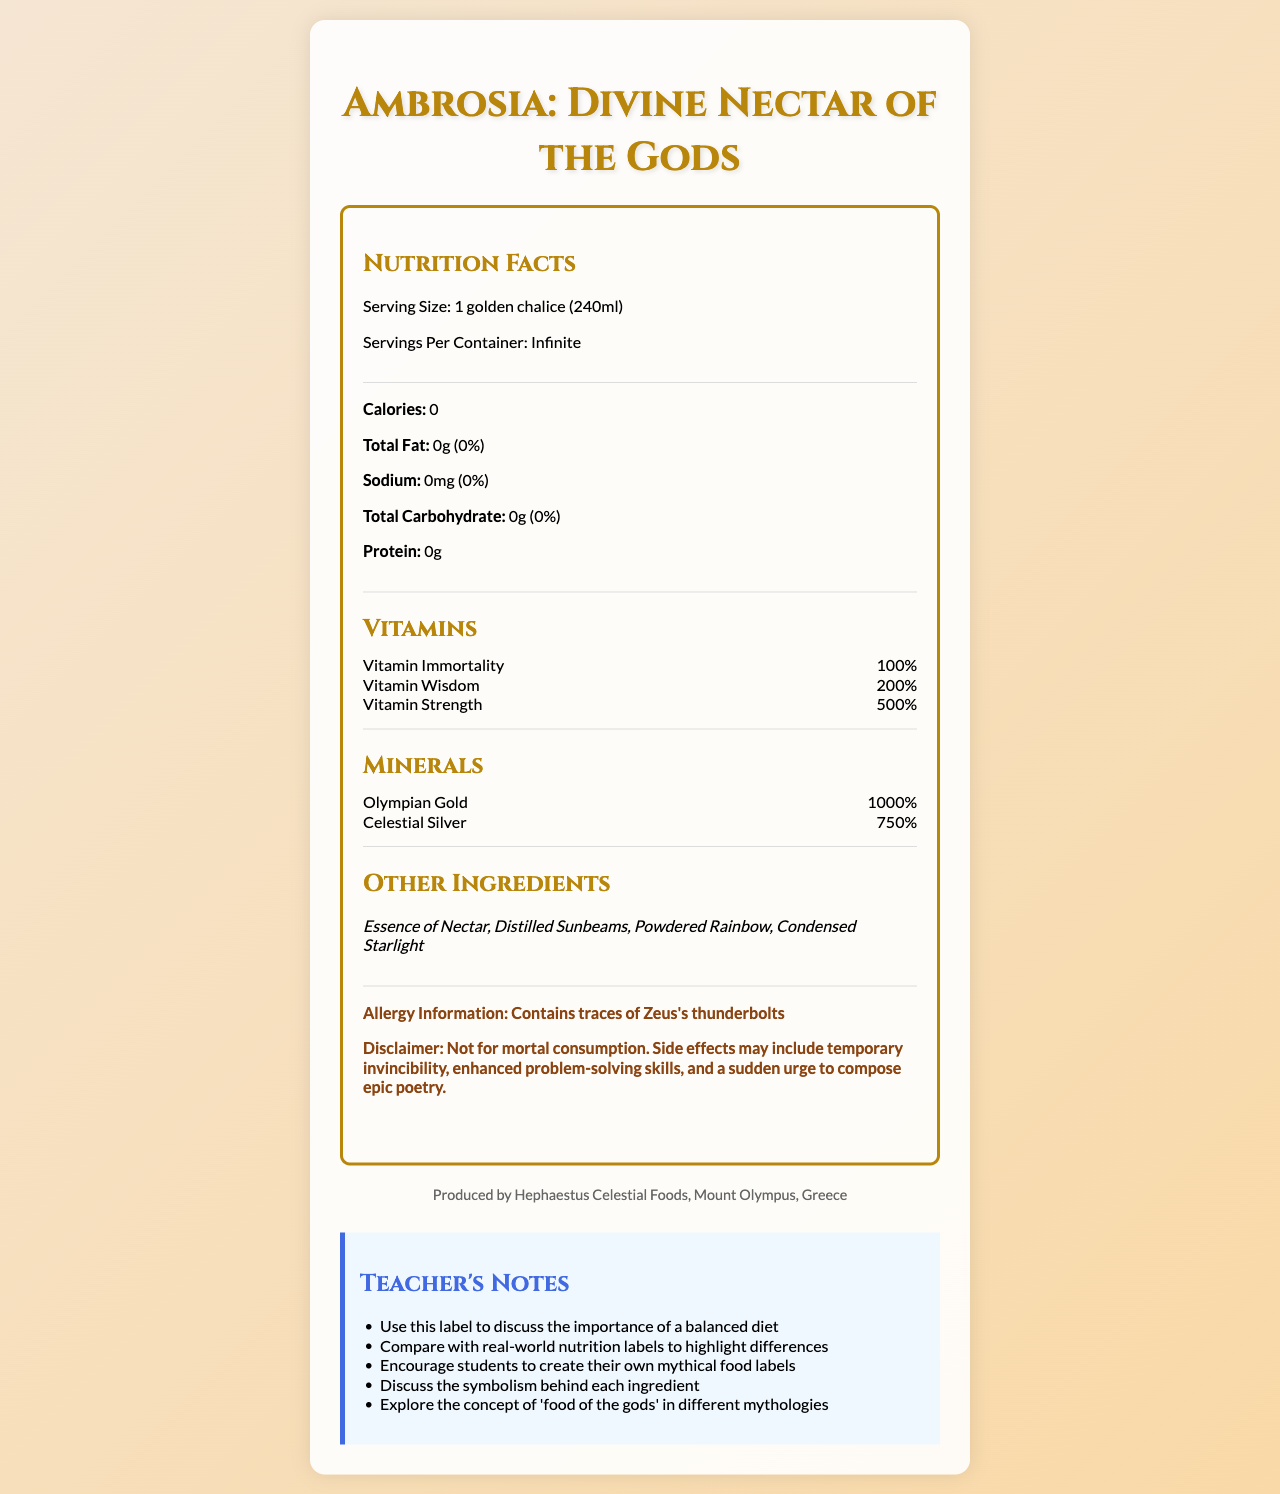What is the serving size of Ambrosia? The serving size is clearly stated as "1 golden chalice (240ml)" in the document.
Answer: 1 golden chalice (240ml) How many servings per container does Ambrosia have? The document specifies that the servings per container are infinite.
Answer: Infinite What is the amount of total fat in Ambrosia? The document shows total fat as "0g".
Answer: 0g How much Vitamin Strength is in Ambrosia? According to the document, Ambrosia contains 500% of Vitamin Strength.
Answer: 500% What are the potential side effects of consuming Ambrosia? The disclaimer section lists these specific side effects.
Answer: Temporary invincibility, enhanced problem-solving skills, and a sudden urge to compose epic poetry Which mineral has the highest daily value percentage in Ambrosia? The document shows that Olympian Gold has a daily value of 1000%, which is the highest among the listed minerals.
Answer: Olympian Gold What does the document warn mortals about Ambrosia? The disclaimer states "Not for mortal consumption".
Answer: Not for mortal consumption What ingredients are listed in Ambrosia? The other ingredients section lists these as the components of Ambrosia.
Answer: Essence of Nectar, Distilled Sunbeams, Powdered Rainbow, Condensed Starlight Who is the manufacturer of Ambrosia? The manufacturer information section specifies this producer.
Answer: Hephaestus Celestial Foods, Mount Olympus, Greece Describe the main idea of the document. The main idea encompasses the nutritional details of Ambrosia, such as its zero calories, the presence of mythical vitamins and minerals, and additional information like ingredients and potential side effects.
Answer: The document is a nutrition label for Ambrosia, detailing serving size, nutritional content, vitamins, minerals, ingredients, allergy information, manufacturer details, and teacher's notes. Does Ambrosia contain any protein? The document lists protein content as 0g, indicating it does not contain any protein.
Answer: No Which of the following is NOT an ingredient in Ambrosia? A. Essence of Nectar B. Lunar Dust C. Powdered Rainbow The document lists Essence of Nectar and Powdered Rainbow as ingredients, but not Lunar Dust.
Answer: B. Lunar Dust Ambrosia includes which of the following minerals? I. Olympian Gold II. Celestial Silver III. Mortal Iron The document lists Olympian Gold and Celestial Silver as minerals, but not Mortal Iron.
Answer: I and II Does Ambrosia contain any allergens? The document mentions it contains traces of Zeus's thunderbolts as an allergen.
Answer: Yes What is the daily value percentage of Vitamin Immortality in Ambrosia? The document states that Vitamin Immortality has a daily value percentage of 100%.
Answer: 100% What are the teacher's notes provided in the document? The teacher's notes section lists these five educational suggestions.
Answer: Discuss the importance of a balanced diet, compare with real-world nutrition labels to highlight differences, encourage students to create their own mythical food labels, discuss the symbolism behind each ingredient, explore the concept of 'food of the gods' in different mythologies What method is used to generate the document? The method to generate the document is not visible in the nutrition label and other related information.
Answer: Cannot be determined 